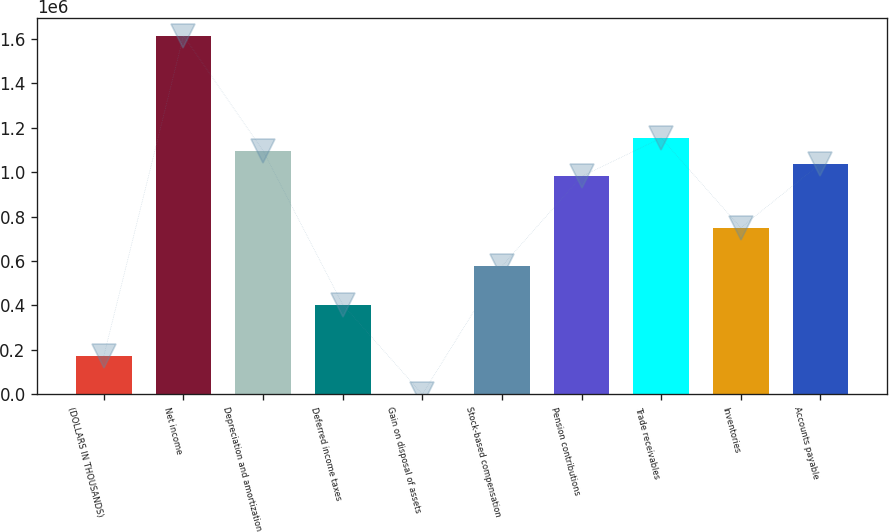<chart> <loc_0><loc_0><loc_500><loc_500><bar_chart><fcel>(DOLLARS IN THOUSANDS)<fcel>Net income<fcel>Depreciation and amortization<fcel>Deferred income taxes<fcel>Gain on disposal of assets<fcel>Stock-based compensation<fcel>Pension contributions<fcel>Trade receivables<fcel>Inventories<fcel>Accounts payable<nl><fcel>173582<fcel>1.61492e+06<fcel>1.09604e+06<fcel>404196<fcel>622<fcel>577156<fcel>980730<fcel>1.15369e+06<fcel>750116<fcel>1.03838e+06<nl></chart> 